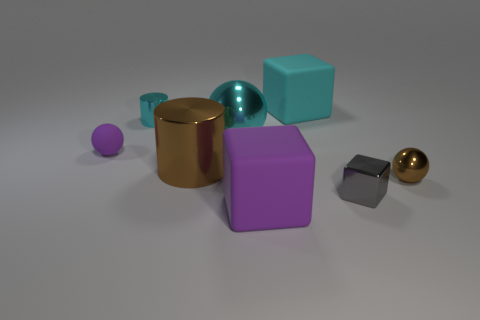Subtract 1 cubes. How many cubes are left? 2 Add 2 big brown matte objects. How many objects exist? 10 Subtract all spheres. How many objects are left? 5 Subtract 0 yellow cylinders. How many objects are left? 8 Subtract all large purple rubber things. Subtract all large things. How many objects are left? 3 Add 8 cyan matte objects. How many cyan matte objects are left? 9 Add 5 small cylinders. How many small cylinders exist? 6 